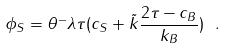<formula> <loc_0><loc_0><loc_500><loc_500>\phi _ { S } = \theta ^ { - } \lambda \tau ( c _ { S } + \tilde { k } \frac { 2 \tau - c _ { B } } { k _ { B } } ) \ .</formula> 